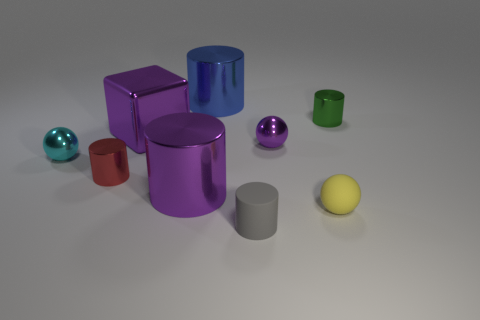Subtract all green cylinders. How many cylinders are left? 4 Subtract all small red cylinders. How many cylinders are left? 4 Subtract 2 cylinders. How many cylinders are left? 3 Subtract all brown cylinders. Subtract all yellow blocks. How many cylinders are left? 5 Add 1 blue shiny cylinders. How many objects exist? 10 Subtract all spheres. How many objects are left? 6 Subtract all green cylinders. Subtract all small green metallic cylinders. How many objects are left? 7 Add 2 red objects. How many red objects are left? 3 Add 5 tiny yellow cubes. How many tiny yellow cubes exist? 5 Subtract 0 cyan blocks. How many objects are left? 9 